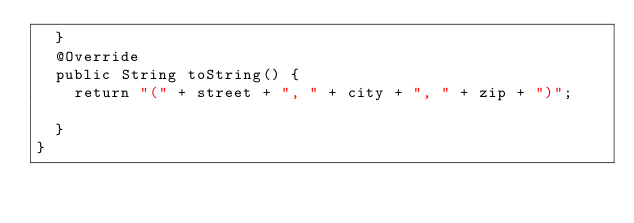<code> <loc_0><loc_0><loc_500><loc_500><_Java_>	}
	@Override
	public String toString() {
		return "(" + street + ", " + city + ", " + zip + ")";
		
	}
}
</code> 